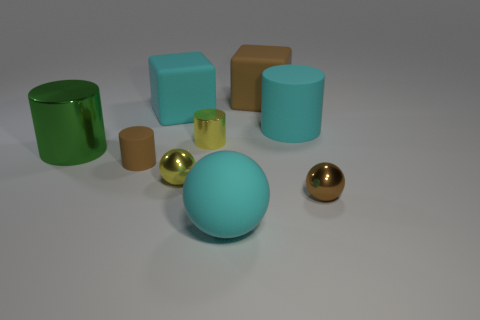What number of other things are there of the same shape as the big green metal thing?
Keep it short and to the point. 3. There is a yellow metallic cylinder; is it the same size as the cyan rubber object that is in front of the tiny brown metal object?
Give a very brief answer. No. How many objects are small brown objects that are on the left side of the large brown matte object or yellow objects?
Your answer should be very brief. 3. The big cyan rubber thing in front of the large rubber cylinder has what shape?
Your answer should be very brief. Sphere. Are there an equal number of cyan spheres behind the small brown metal object and cyan matte blocks in front of the yellow cylinder?
Offer a terse response. Yes. What is the color of the large rubber thing that is behind the tiny brown ball and to the left of the large brown object?
Your answer should be very brief. Cyan. There is a small object that is behind the matte cylinder that is on the left side of the cyan cylinder; what is it made of?
Your answer should be very brief. Metal. Does the matte sphere have the same size as the green metallic object?
Your response must be concise. Yes. What number of tiny objects are yellow spheres or yellow cylinders?
Make the answer very short. 2. What number of rubber cylinders are in front of the big green thing?
Give a very brief answer. 1. 